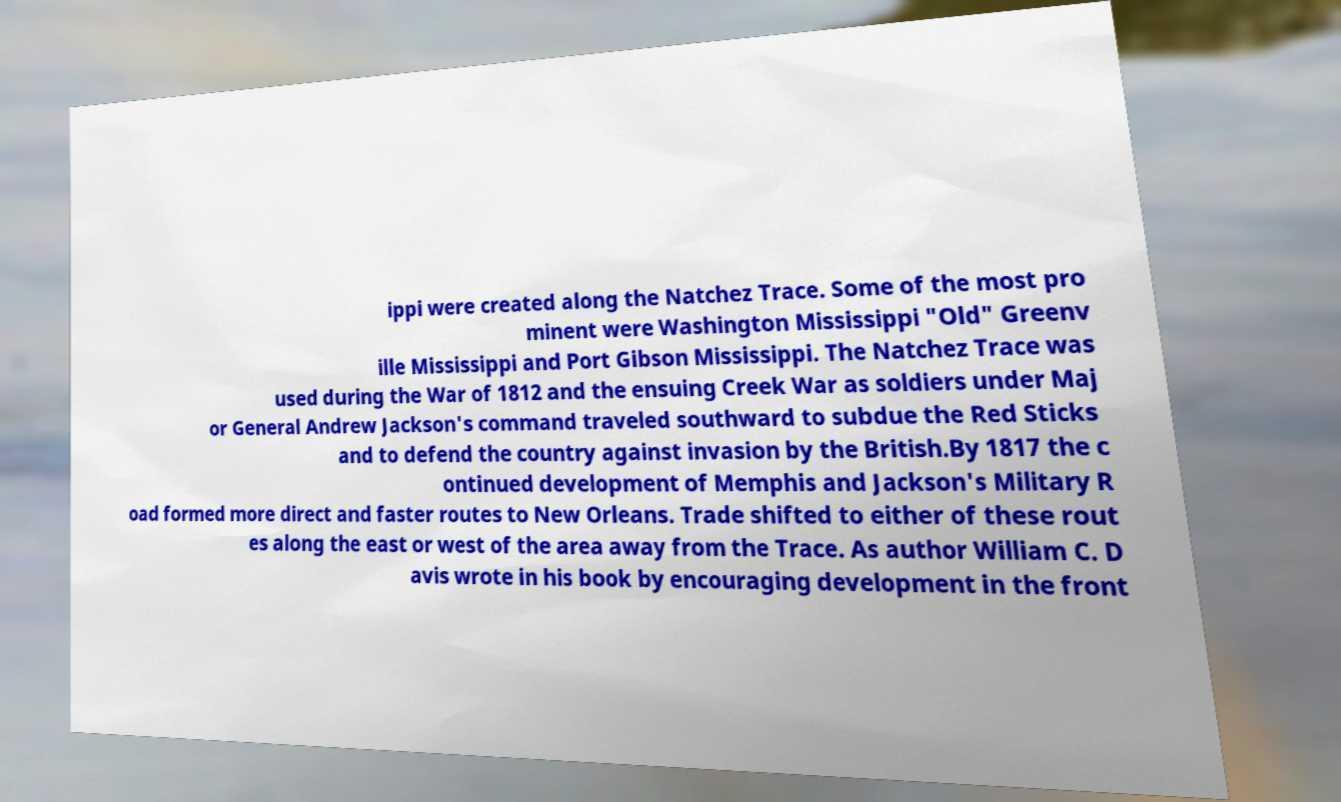For documentation purposes, I need the text within this image transcribed. Could you provide that? ippi were created along the Natchez Trace. Some of the most pro minent were Washington Mississippi "Old" Greenv ille Mississippi and Port Gibson Mississippi. The Natchez Trace was used during the War of 1812 and the ensuing Creek War as soldiers under Maj or General Andrew Jackson's command traveled southward to subdue the Red Sticks and to defend the country against invasion by the British.By 1817 the c ontinued development of Memphis and Jackson's Military R oad formed more direct and faster routes to New Orleans. Trade shifted to either of these rout es along the east or west of the area away from the Trace. As author William C. D avis wrote in his book by encouraging development in the front 